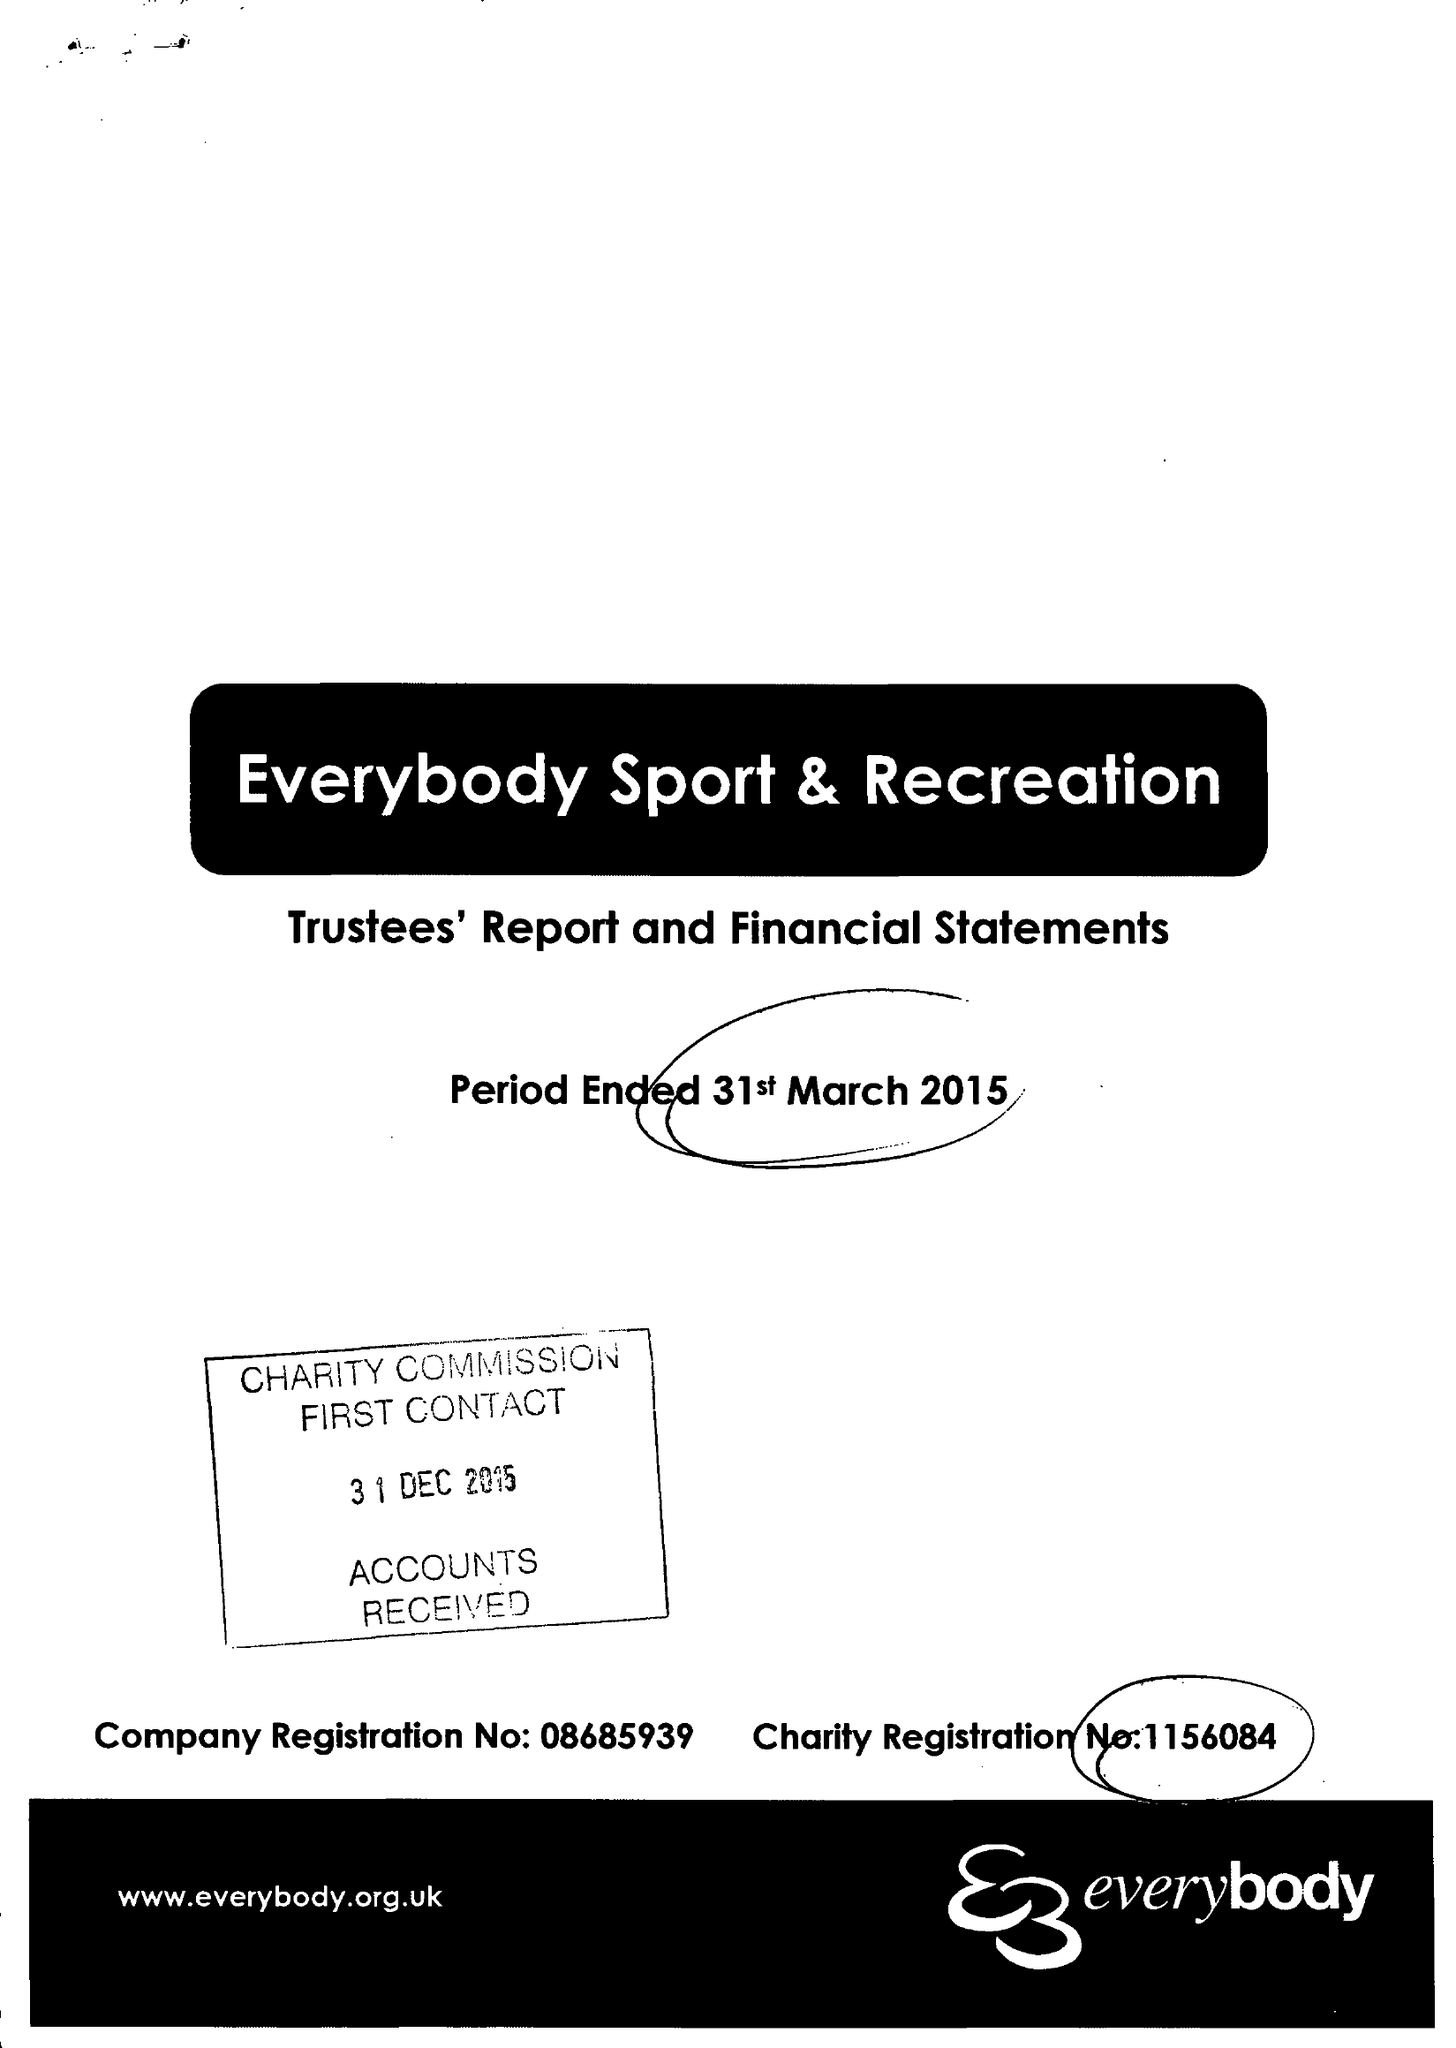What is the value for the address__post_town?
Answer the question using a single word or phrase. CREWE 